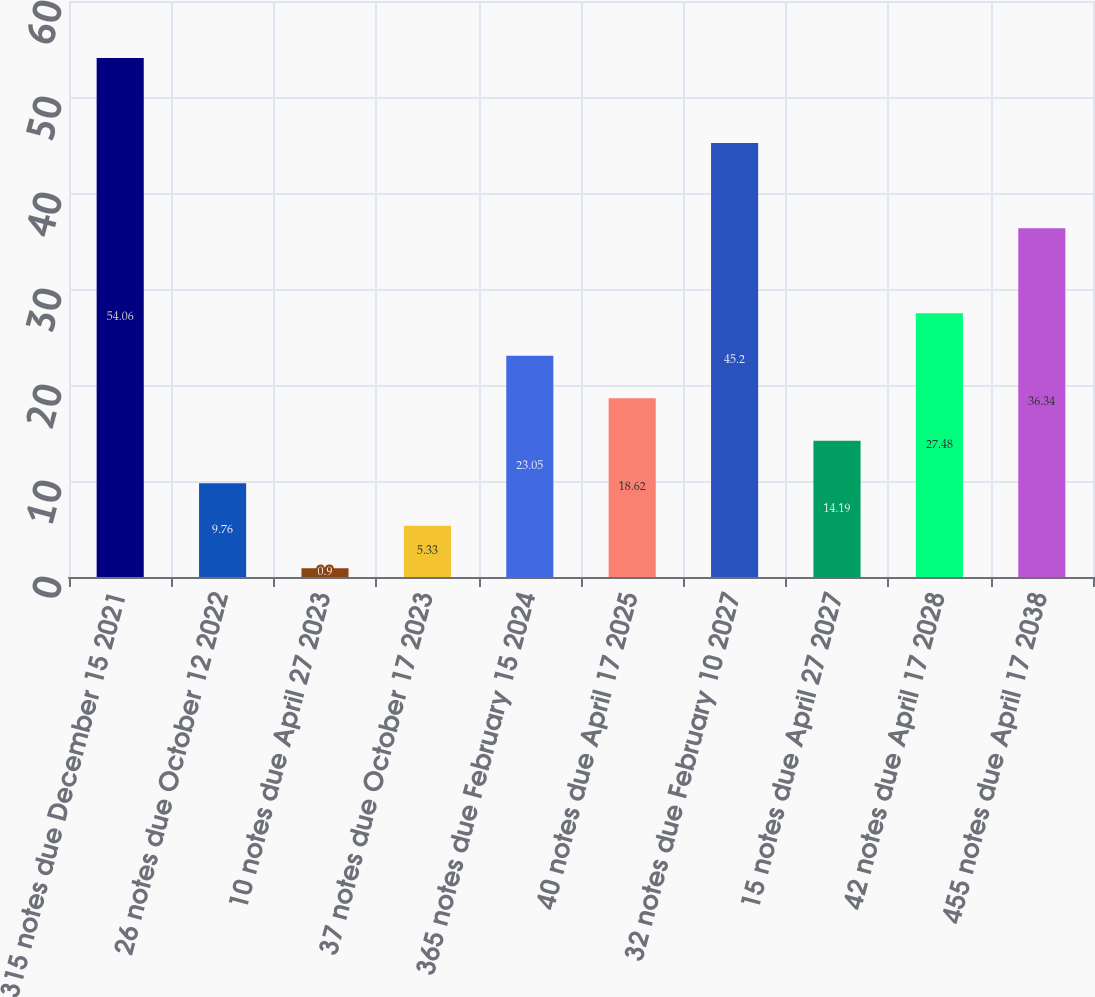Convert chart. <chart><loc_0><loc_0><loc_500><loc_500><bar_chart><fcel>315 notes due December 15 2021<fcel>26 notes due October 12 2022<fcel>10 notes due April 27 2023<fcel>37 notes due October 17 2023<fcel>365 notes due February 15 2024<fcel>40 notes due April 17 2025<fcel>32 notes due February 10 2027<fcel>15 notes due April 27 2027<fcel>42 notes due April 17 2028<fcel>455 notes due April 17 2038<nl><fcel>54.06<fcel>9.76<fcel>0.9<fcel>5.33<fcel>23.05<fcel>18.62<fcel>45.2<fcel>14.19<fcel>27.48<fcel>36.34<nl></chart> 